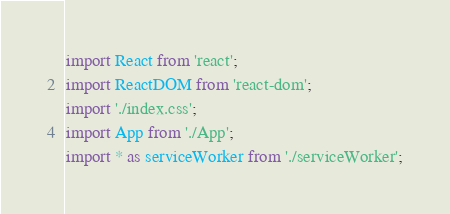Convert code to text. <code><loc_0><loc_0><loc_500><loc_500><_JavaScript_>import React from 'react';
import ReactDOM from 'react-dom';
import './index.css';
import App from './App';
import * as serviceWorker from './serviceWorker';
</code> 